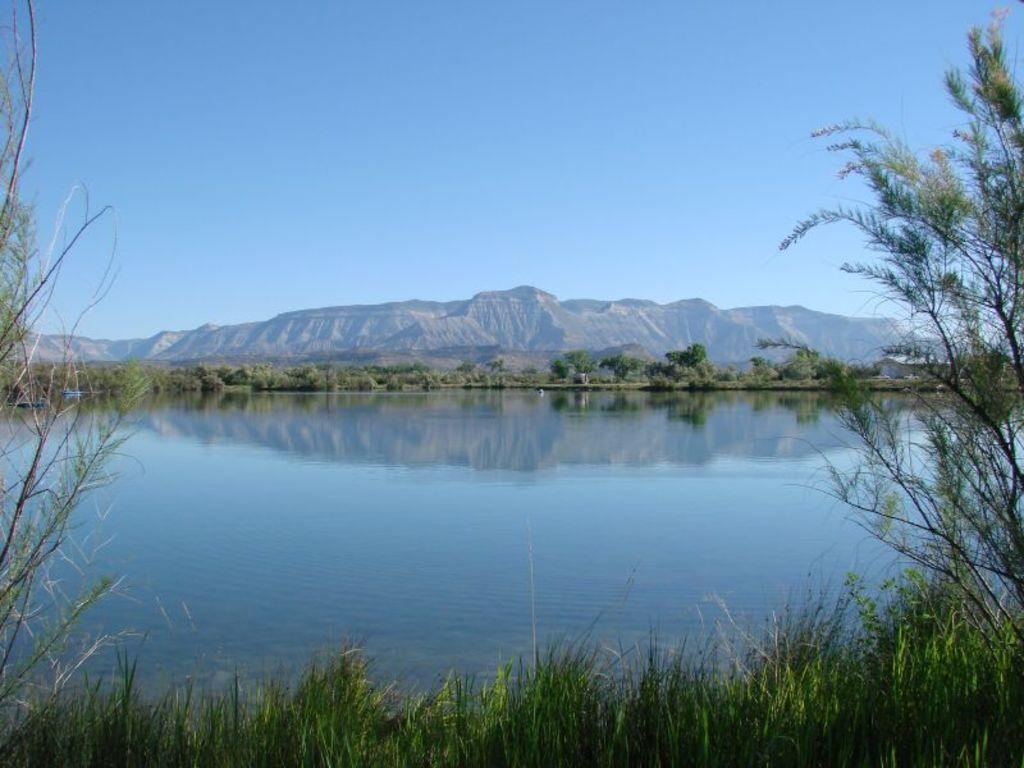Could you give a brief overview of what you see in this image? In this image, It looks like a lake. At the bottom of the image, I think this is the grass. At the center of the image, I can see the trees and hills. At the top of the image, I can see the sky. 